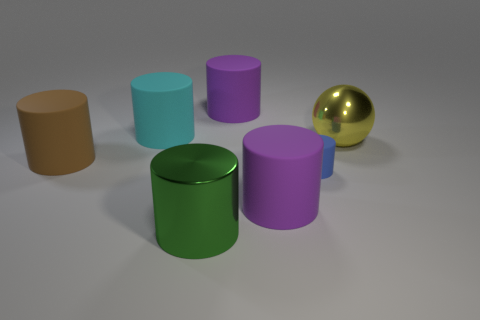Subtract all cyan matte cylinders. How many cylinders are left? 5 Subtract all cyan cylinders. How many cylinders are left? 5 Subtract all blue cylinders. Subtract all red balls. How many cylinders are left? 5 Add 1 small gray cylinders. How many objects exist? 8 Subtract all balls. How many objects are left? 6 Add 6 tiny cylinders. How many tiny cylinders exist? 7 Subtract 0 yellow cylinders. How many objects are left? 7 Subtract all tiny green metallic cylinders. Subtract all green metal objects. How many objects are left? 6 Add 6 small blue cylinders. How many small blue cylinders are left? 7 